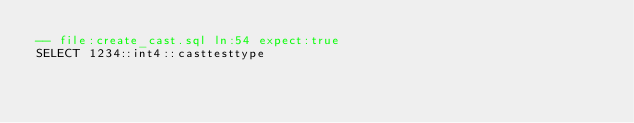<code> <loc_0><loc_0><loc_500><loc_500><_SQL_>-- file:create_cast.sql ln:54 expect:true
SELECT 1234::int4::casttesttype
</code> 